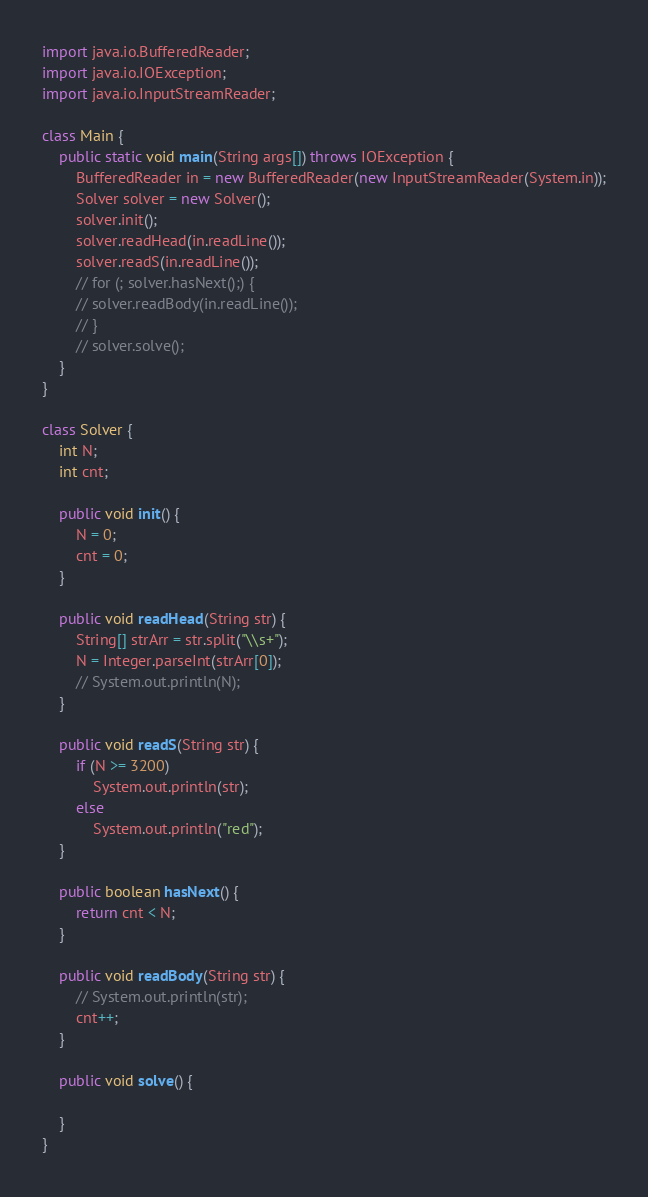Convert code to text. <code><loc_0><loc_0><loc_500><loc_500><_Java_>import java.io.BufferedReader;
import java.io.IOException;
import java.io.InputStreamReader;

class Main {
	public static void main(String args[]) throws IOException {
		BufferedReader in = new BufferedReader(new InputStreamReader(System.in));
		Solver solver = new Solver();
		solver.init();
		solver.readHead(in.readLine());
		solver.readS(in.readLine());
		// for (; solver.hasNext();) {
		// solver.readBody(in.readLine());
		// }
		// solver.solve();
	}
}

class Solver {
	int N;
	int cnt;

	public void init() {
		N = 0;
		cnt = 0;
	}

	public void readHead(String str) {
		String[] strArr = str.split("\\s+");
		N = Integer.parseInt(strArr[0]);
		// System.out.println(N);
	}

	public void readS(String str) {
		if (N >= 3200)
			System.out.println(str);
		else
			System.out.println("red");
	}

	public boolean hasNext() {
		return cnt < N;
	}

	public void readBody(String str) {
		// System.out.println(str);
		cnt++;
	}

	public void solve() {

	}
}
</code> 